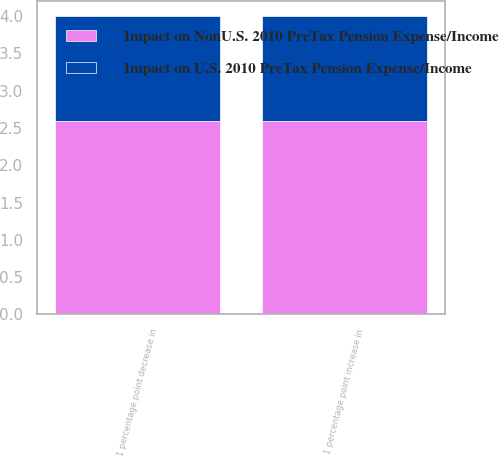<chart> <loc_0><loc_0><loc_500><loc_500><stacked_bar_chart><ecel><fcel>1 percentage point decrease in<fcel>1 percentage point increase in<nl><fcel>Impact on NonU.S. 2010 PreTax Pension Expense/Income<fcel>2.6<fcel>2.6<nl><fcel>Impact on U.S. 2010 PreTax Pension Expense/Income<fcel>1.4<fcel>1.4<nl></chart> 